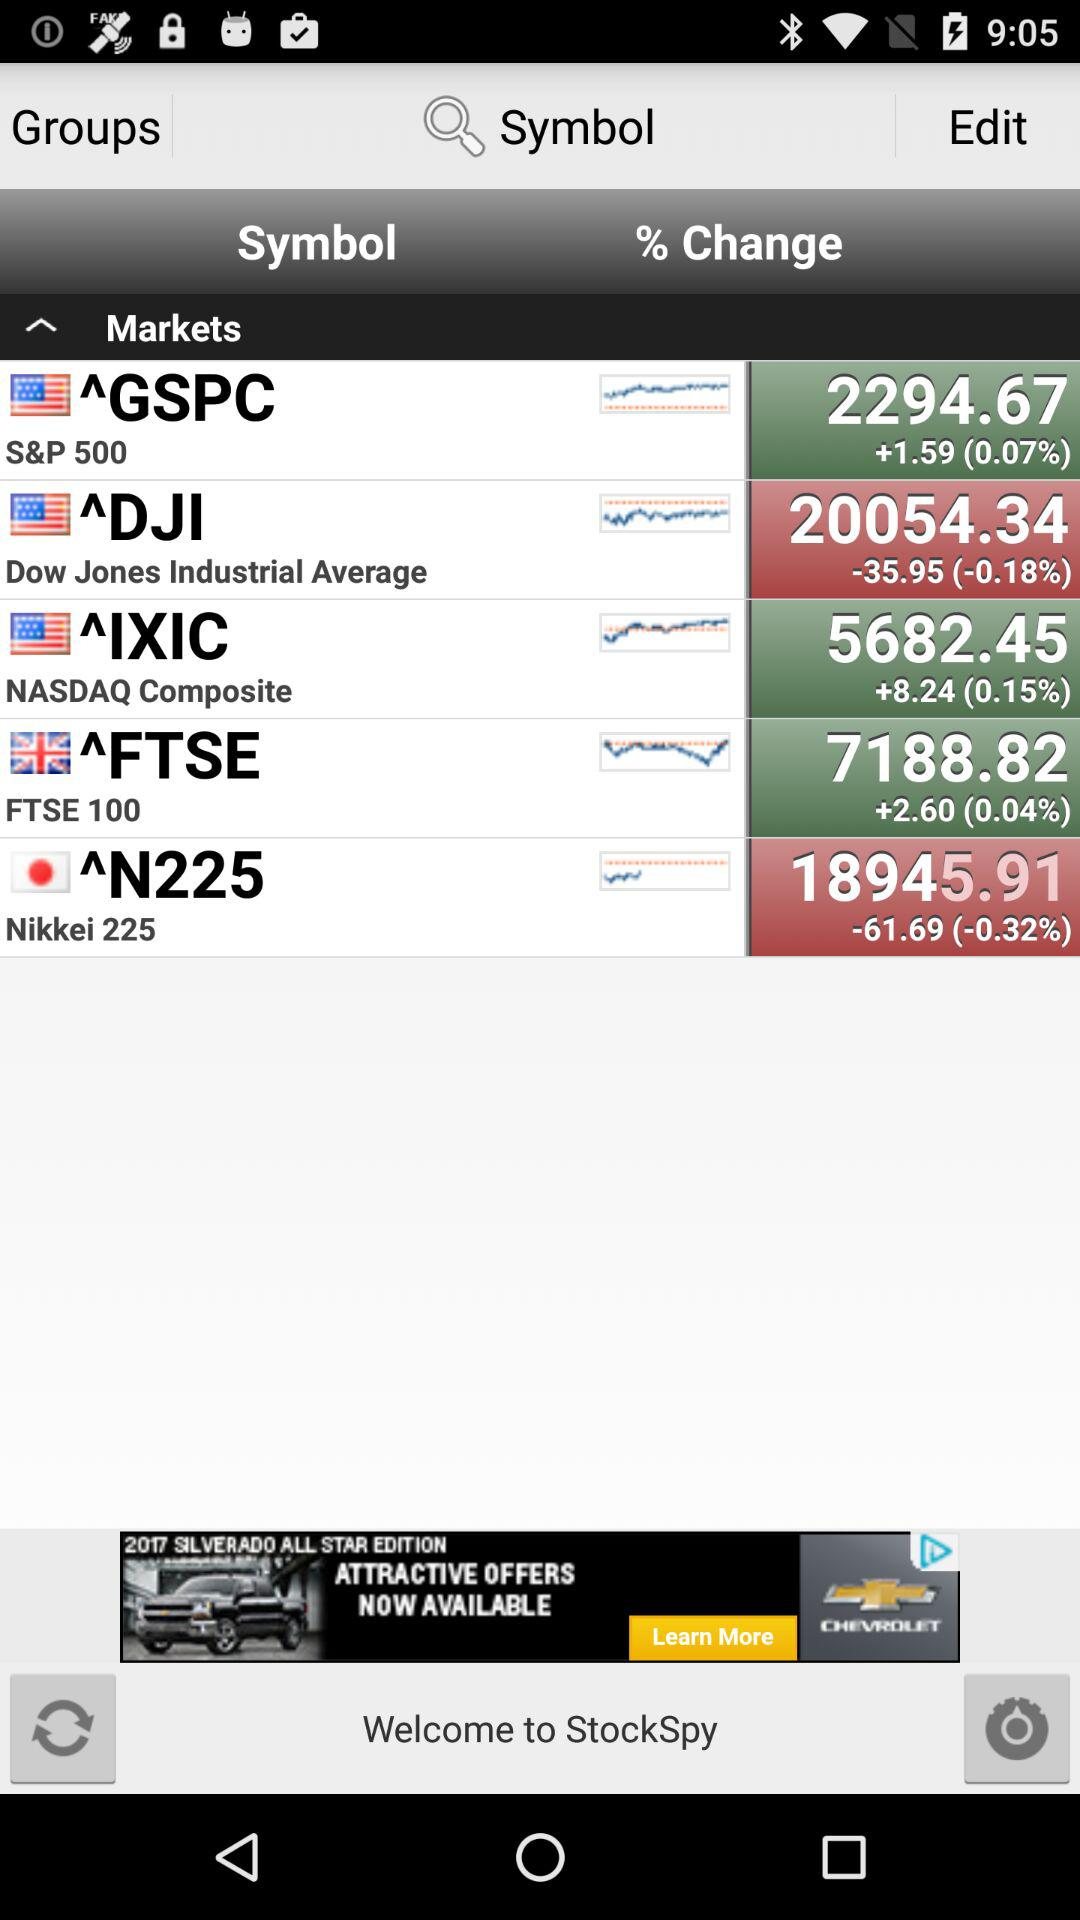How much has the Dow Jones Industrial Average fallen since it was last updated?
Answer the question using a single word or phrase. -35.95 